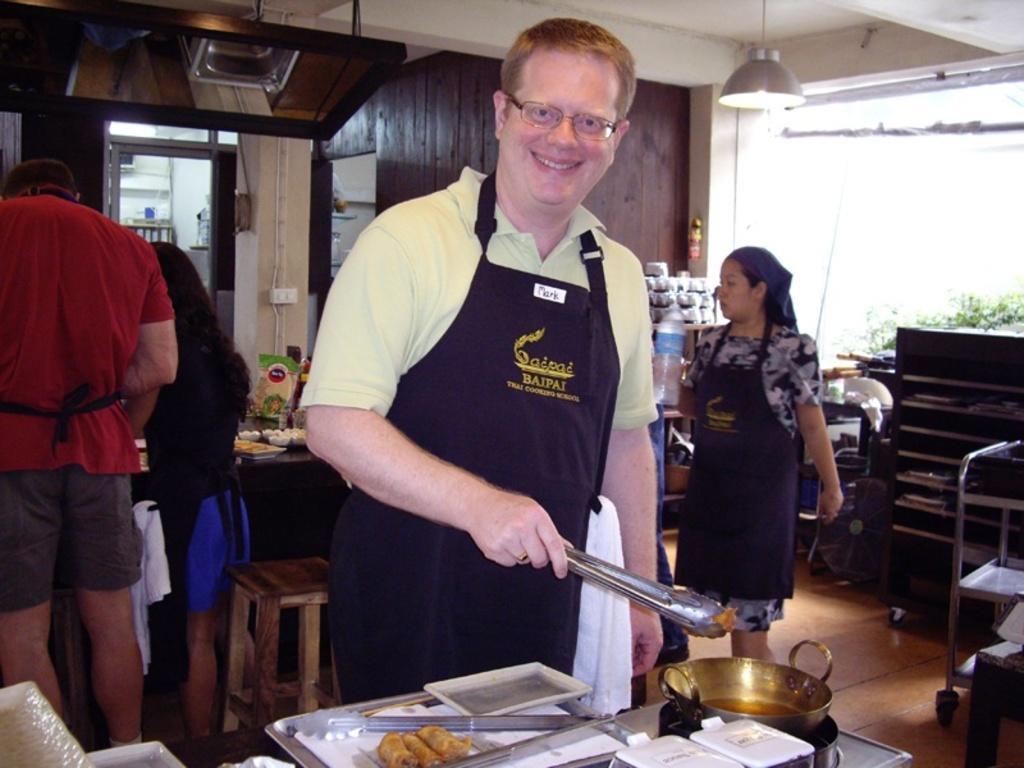Can you describe this image briefly? This picture is clicked inside. In the center there is a man wearing a black color apron, smiling, holding a metal object and seems to be cooking. In the foreground there is a table on the top of which chopping board, knife and some other items are placed. On the right there is a woman wearing apron and seems to be standing on the ground. On the left we can see the group of people standing on the ground. In the background we can see the chimney, lamp hanging on the roof and a table on the top of which many number of items are placed and we can see the wall and many other objects. 